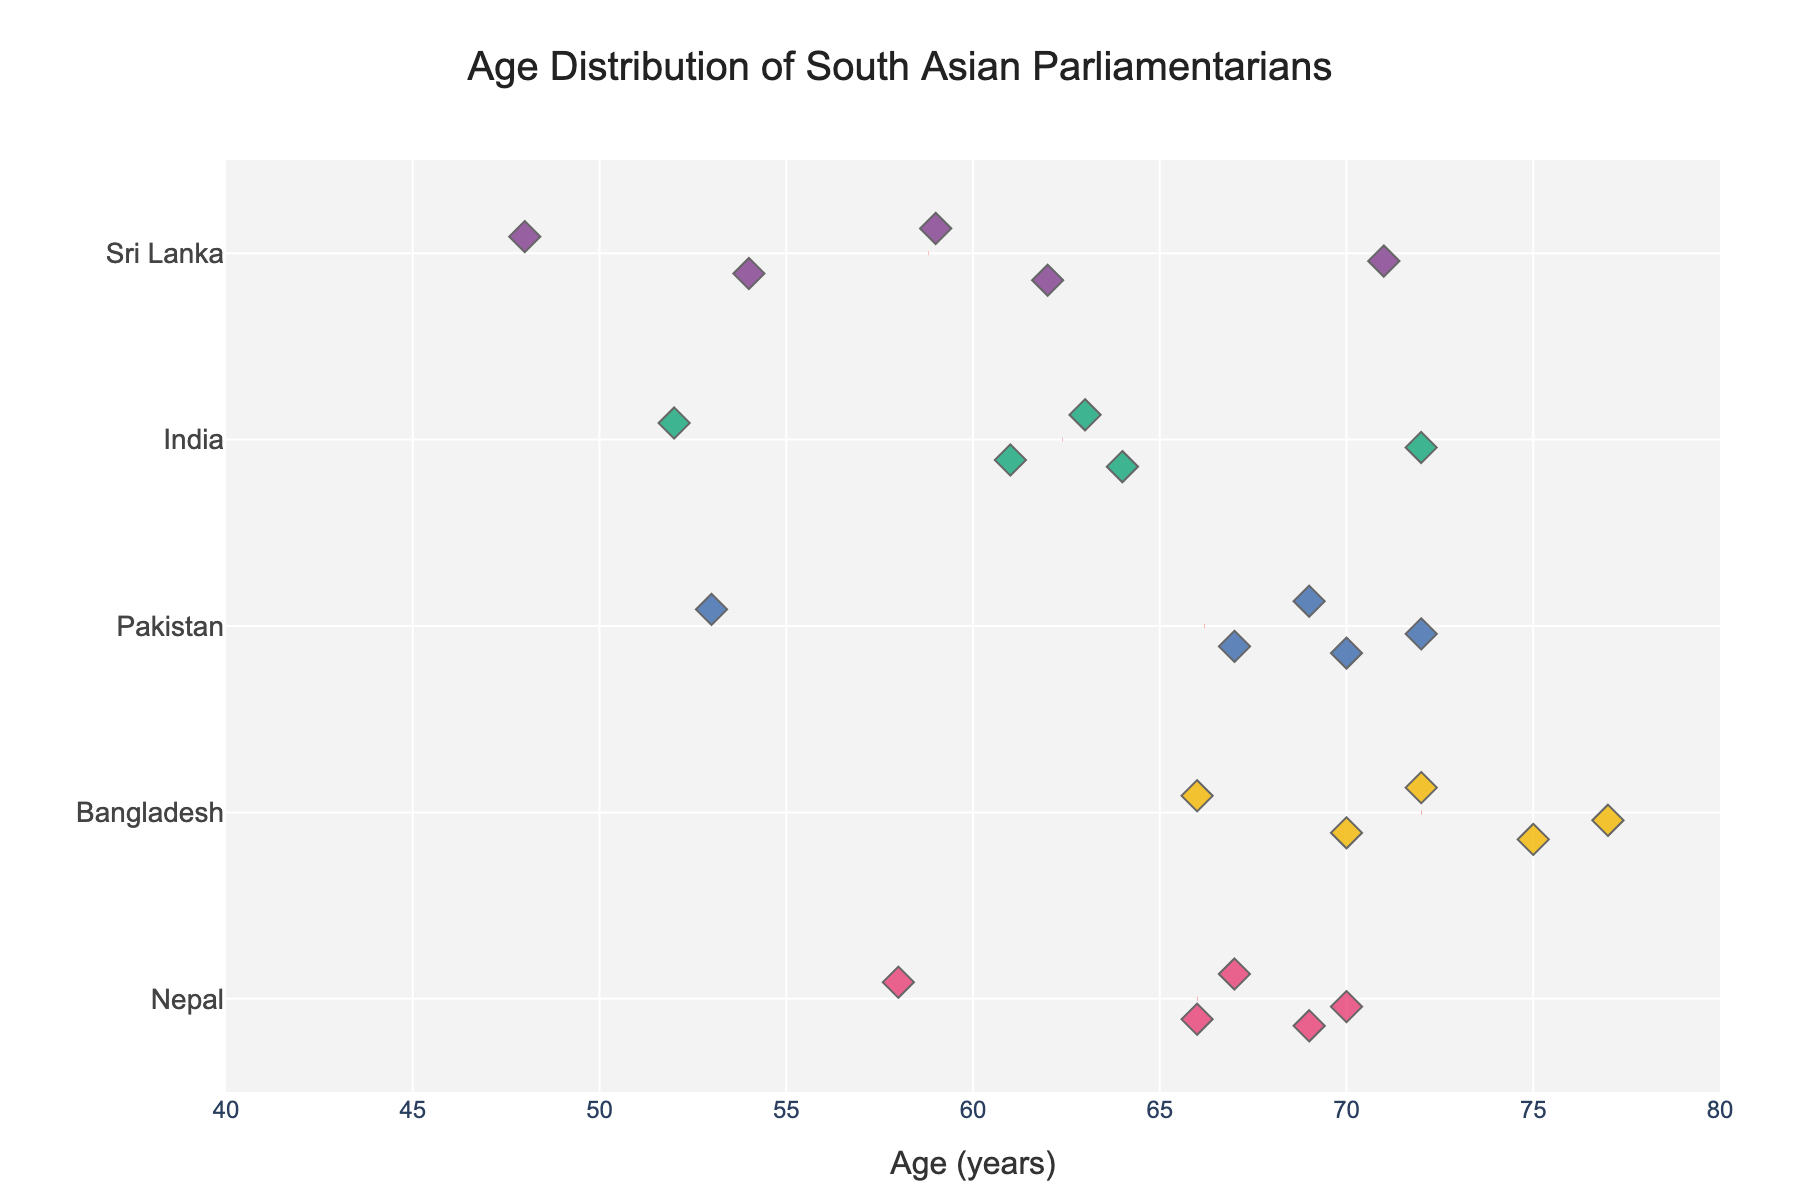What is the age range of Sri Lankan parliamentarians shown in the figure? To find the age range of Sri Lankan parliamentarians, we look at the minimum and maximum ages for the individuals from Sri Lanka. The youngest is Namal Rajapaksa (48) and the oldest is Ranil Wickremesinghe (71).
Answer: 48-71 Which country's parliamentarians have the highest mean age? To determine this, we need to examine the mean age lines for each country. The country with the highest positioned mean age line will be the one with the highest mean age. Bangladesh has the highest mean age line.
Answer: Bangladesh Who is the youngest parliamentarian from Pakistan shown in the figure? To find the youngest parliamentarian from Pakistan, look for the lowest age dot corresponding to Pakistan. Bilawal Bhutto Zardari is the youngest at age 53.
Answer: Bilawal Bhutto Zardari How does the age distribution of Sri Lankan parliamentarians compare to Indian parliamentarians? To compare the age distributions, observe the spread of the data points (dots) for Sri Lanka and India. Indian parliamentarians have a wider age range (52-72) compared to Sri Lankan parliamentarians (48-71), with a noticeable clustering around the higher age values in India.
Answer: India's distribution is wider and slightly older What is the mean age of Nepalese parliamentarians as shown by the figure? To find the mean age, look for the dashed mean age line for Nepal. It is approximately located at the age 66.6.
Answer: 66.6 Which Sri Lankan parliamentarian is closest in age to Indian parliamentarian Mamata Banerjee? By comparing the ages, we see that Mamata Banerjee is 63. The closest Sri Lankan parliamentarian in age is Ranil Wickremesinghe, who is 1 year older at 71.
Answer: Ranil Wickremesinghe How many parliamentarians in total are represented in the figure? Count the total number of dots (representing parliamentarians) across all countries in the figure. There are 20 parliamentarians in total.
Answer: 20 Are there any Bangladeshi parliamentarians younger than the youngest Sri Lankan parliamentarian? The youngest Sri Lankan parliamentarian is Namal Rajapaksa at 48. By inspecting the ages of Bangladeshi parliamentarians, all of them are older than 48.
Answer: No What is the age of the oldest Nepalese parliamentarian? To find this, look for the highest age dot corresponding to Nepal. The oldest is Sher Bahadur Deuba, aged 70.
Answer: 70 